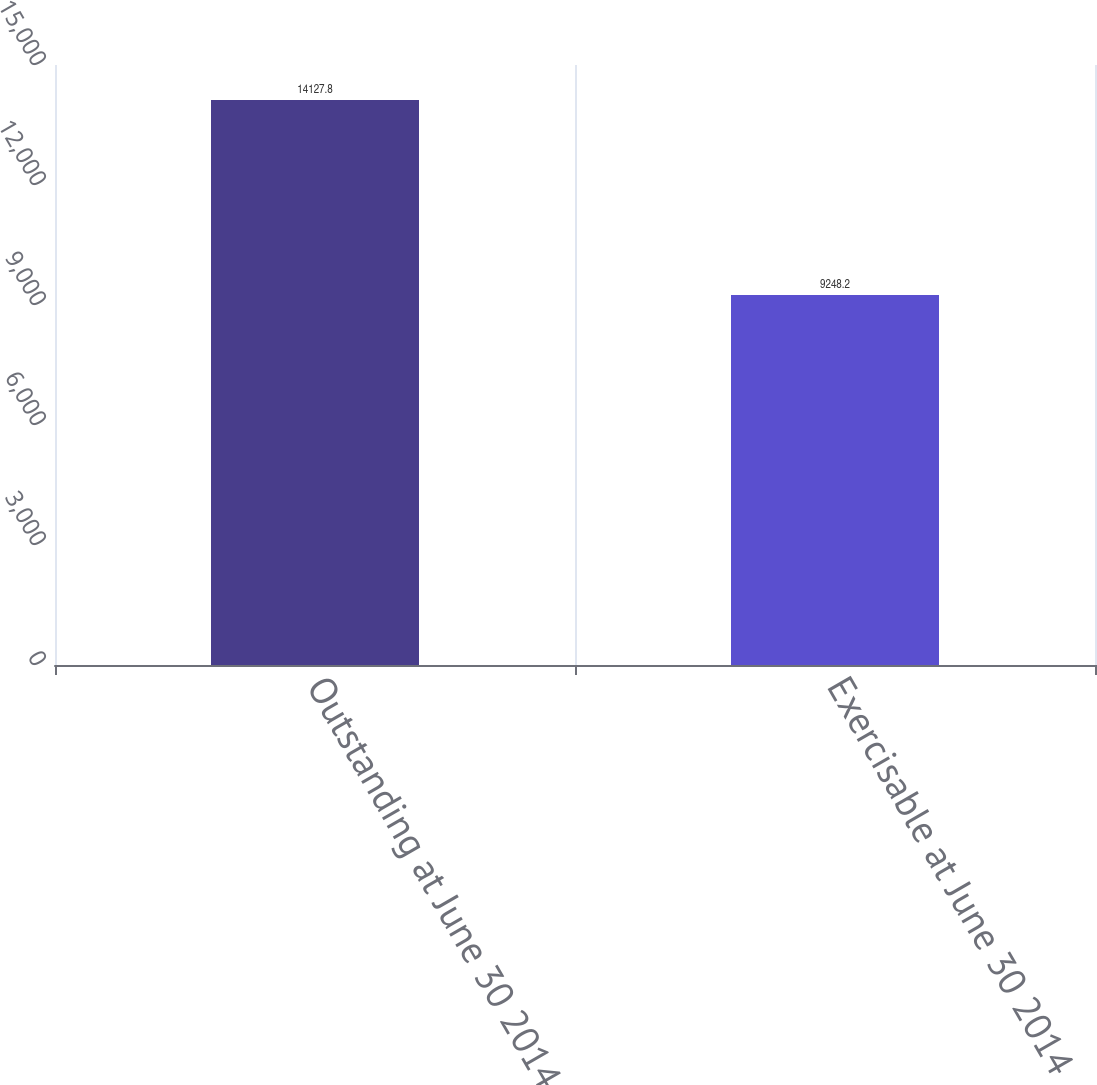Convert chart. <chart><loc_0><loc_0><loc_500><loc_500><bar_chart><fcel>Outstanding at June 30 2014<fcel>Exercisable at June 30 2014<nl><fcel>14127.8<fcel>9248.2<nl></chart> 